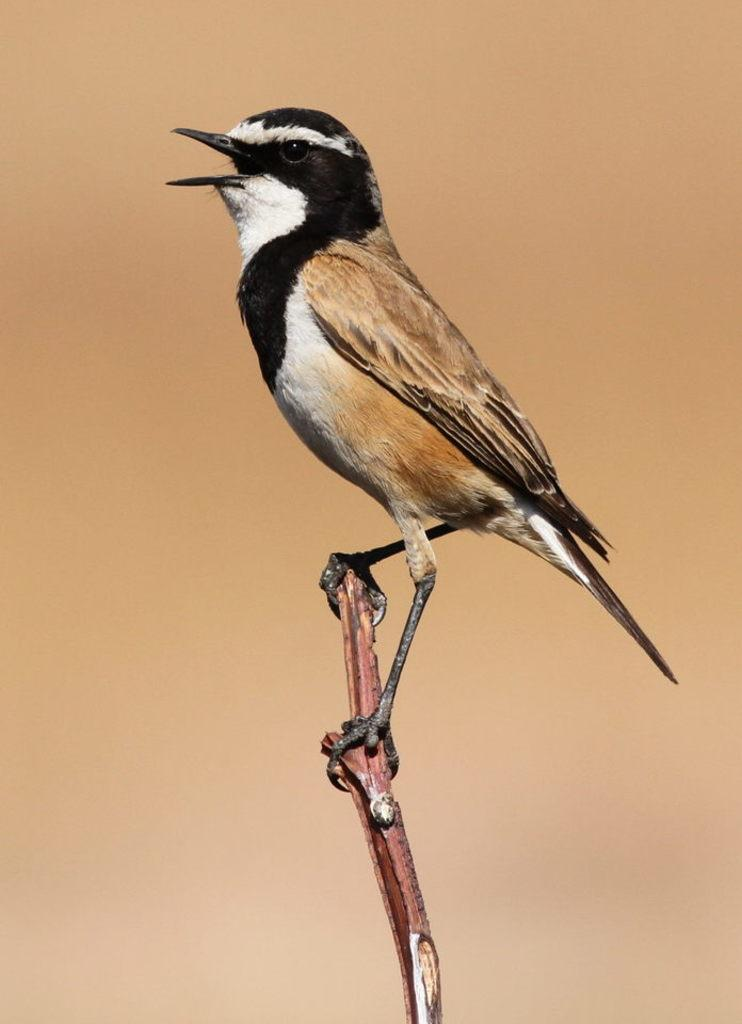What type of animal is in the image? There is a bird in the image. Where is the bird located? The bird is on a stem. Can you describe the background of the image? The background of the image has a blurred view. What type of cast can be seen on the bird's wing in the image? There is no cast present on the bird's wing in the image. What is the bird's temper like in the image? The bird's temper cannot be determined from the image, as it is a still photograph. 